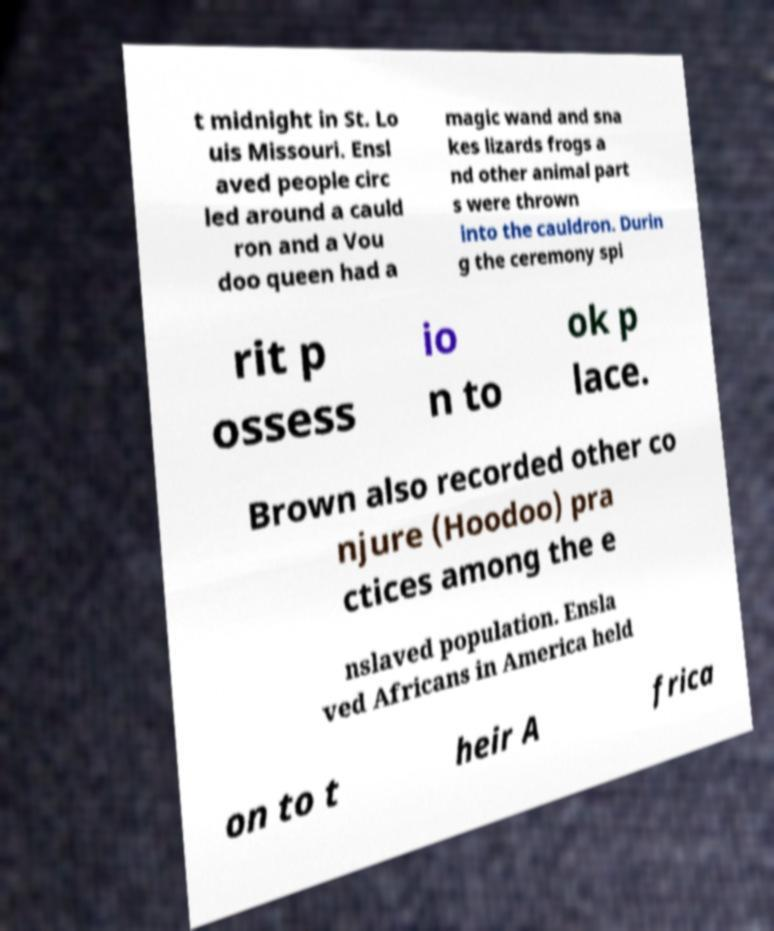There's text embedded in this image that I need extracted. Can you transcribe it verbatim? t midnight in St. Lo uis Missouri. Ensl aved people circ led around a cauld ron and a Vou doo queen had a magic wand and sna kes lizards frogs a nd other animal part s were thrown into the cauldron. Durin g the ceremony spi rit p ossess io n to ok p lace. Brown also recorded other co njure (Hoodoo) pra ctices among the e nslaved population. Ensla ved Africans in America held on to t heir A frica 